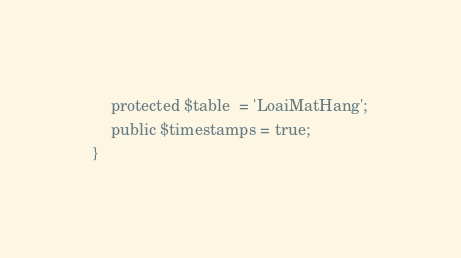<code> <loc_0><loc_0><loc_500><loc_500><_PHP_>    protected $table  = 'LoaiMatHang';
    public $timestamps = true;
}
</code> 